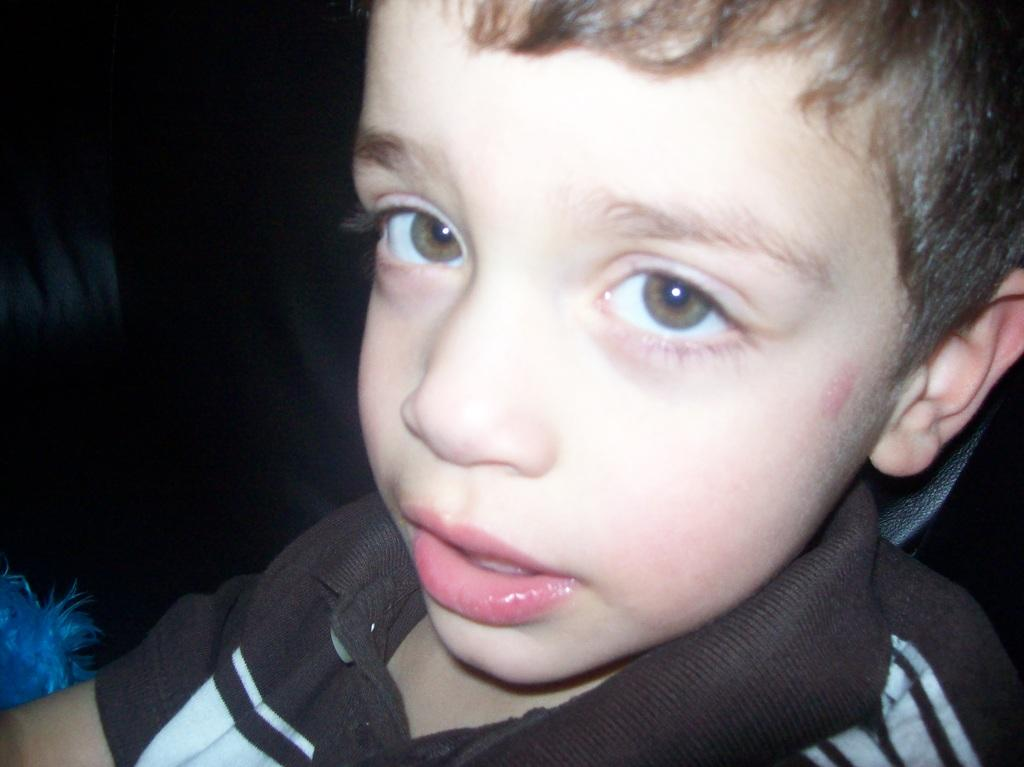What is the main subject of the image? The main subject of the image is a boy. What is the boy wearing in the image? The boy is wearing a shirt in the image. Can you see any jellyfish near the island in the image? There is no island or jellyfish present in the image; it features a boy wearing a shirt. 